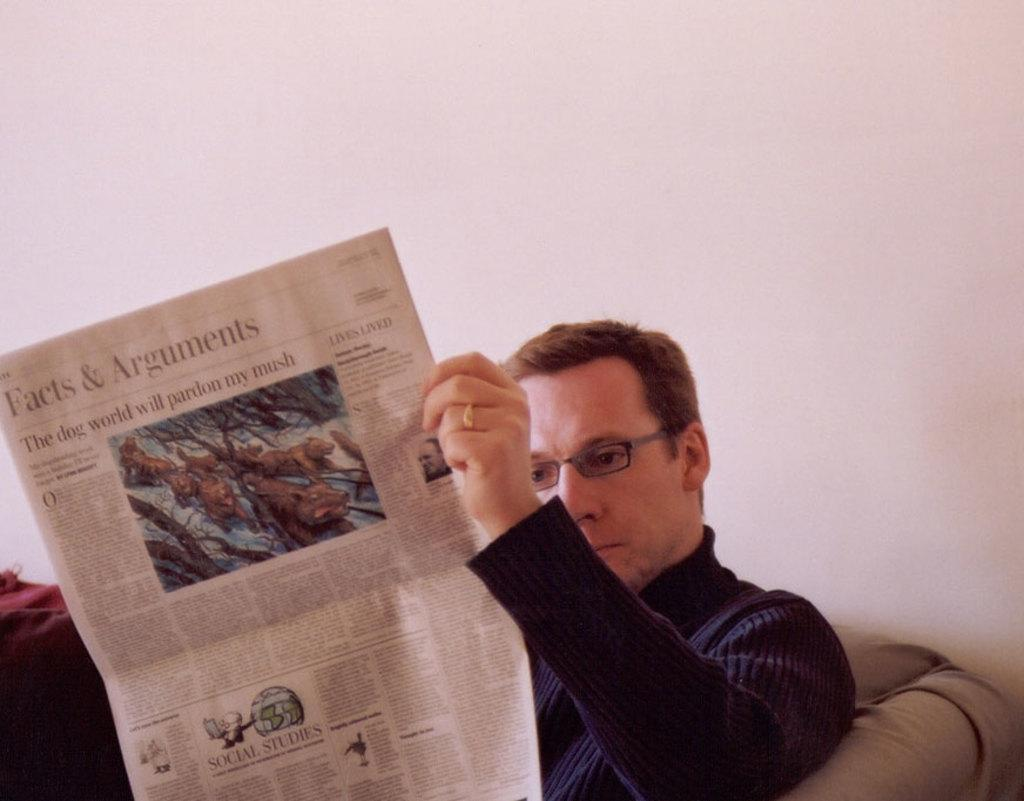Who is present in the image? There is a person in the image. What is the person holding? The person is holding a paper. Where is the person sitting? The person is sitting on a sofa. What is behind the person? The person is in front of a wall. What is the person wearing? The person is wearing clothes. What accessory is the person wearing? The person is wearing spectacles. What type of yoke can be seen in the image? There is no yoke present in the image. What activity is the person teaching in the image? The image does not show the person teaching, nor is there any indication of teaching in the image. 